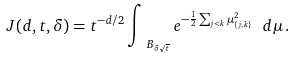Convert formula to latex. <formula><loc_0><loc_0><loc_500><loc_500>J ( d , t , \delta ) = t ^ { - d / 2 } \int _ { \ B _ { \delta \sqrt { t } } } e ^ { - \frac { 1 } { 2 } \sum _ { j < k } \mu _ { \{ j , k \} } ^ { 2 } } \ d \mu \, .</formula> 